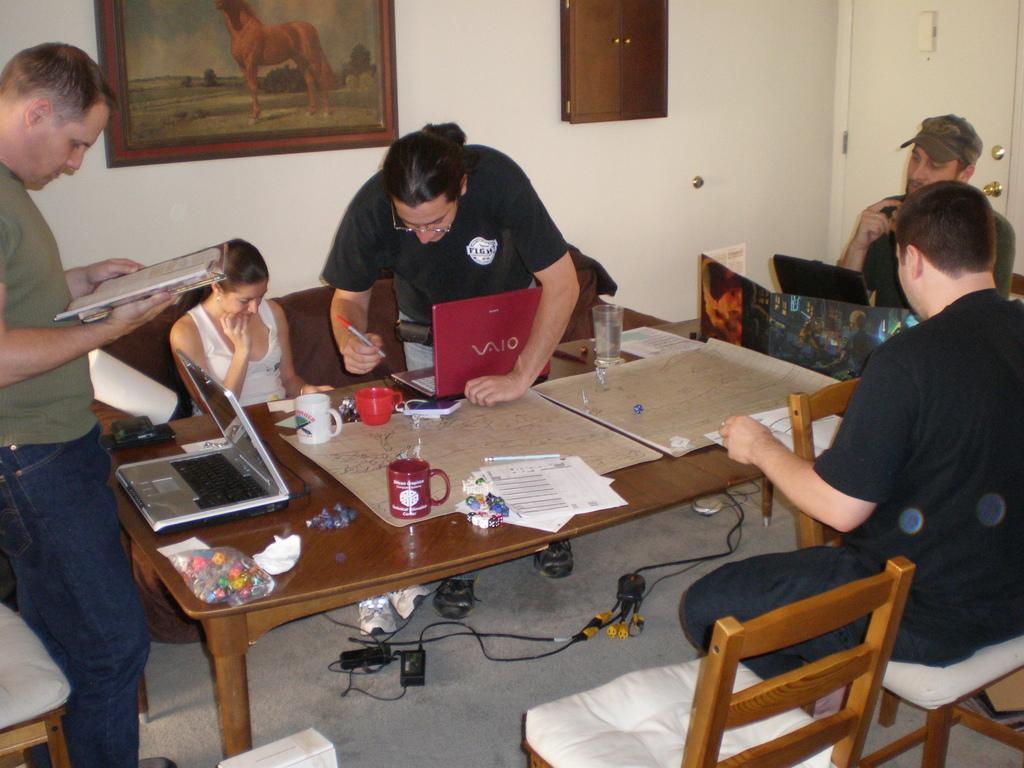Could you give a brief overview of what you see in this image? This image is clicked in a room. There are sofas, chairs and tables in this image. The table is placed in the middle, on that table there are papers, mug, laptop ,glass and book. People are sitting on chairs. There is a photo frame on the top. There is door on the top right corner ,there are wires in the bottom. 